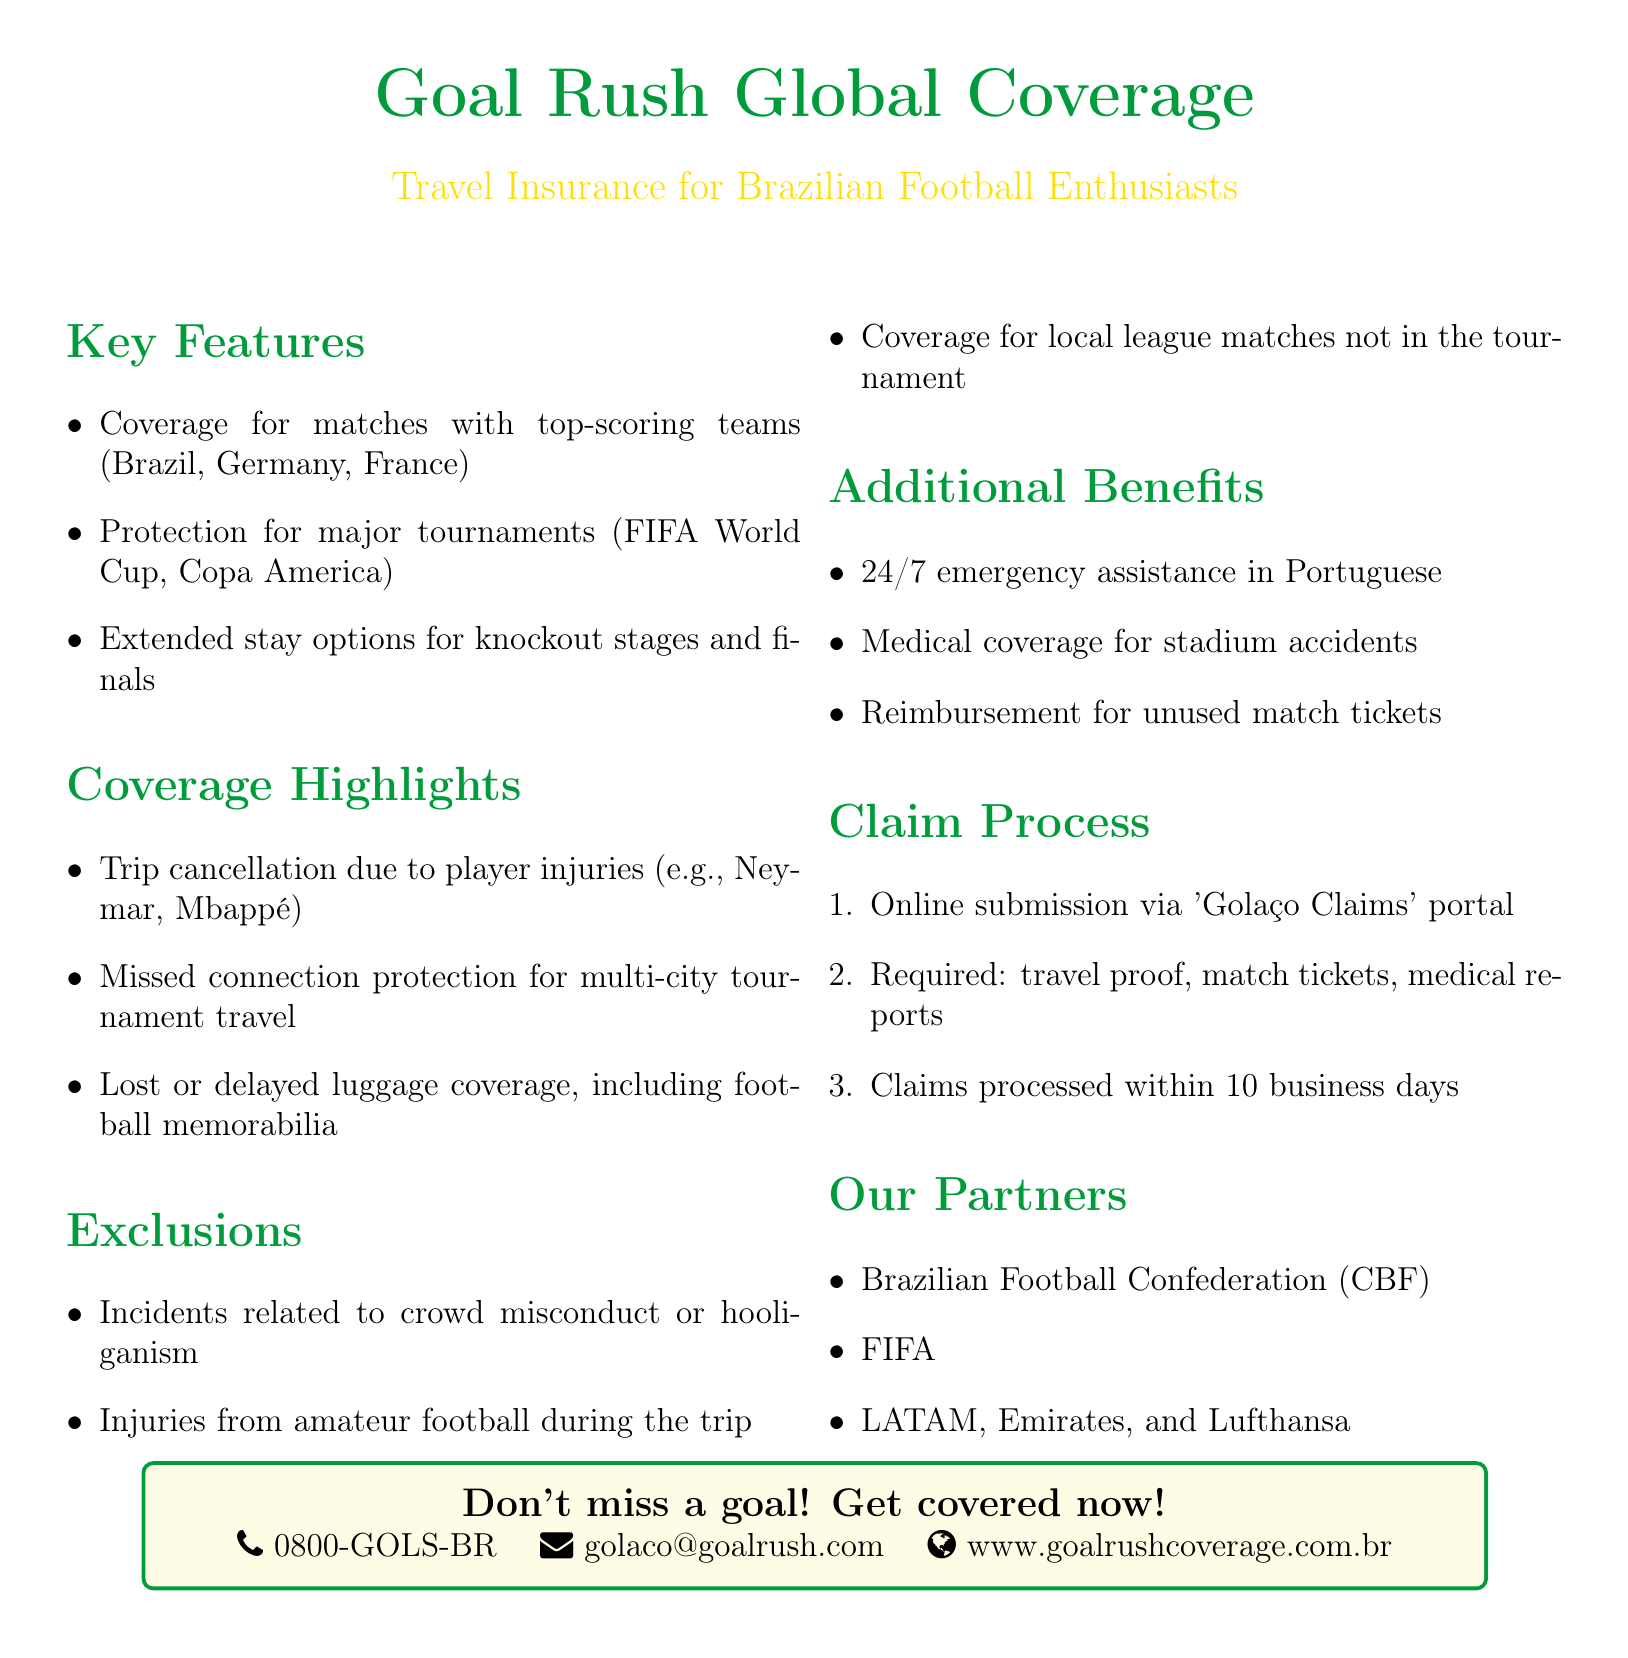What teams are covered by the insurance? The document lists the teams covered under the insurance policy, specifically noting top-scoring teams.
Answer: Brazil, Germany, France What tournaments are included in the coverage? The coverage specifically mentions major international tournaments for football enthusiasts.
Answer: FIFA World Cup, Copa America What is the coverage for missed connections? The document highlights various protection options included with the insurance policy.
Answer: Missed connection protection for multi-city tournament travel What are the exclusions related to player injuries? The policy states what kinds of incidents or activities are not covered under the insurance plan.
Answer: Incidents related to crowd misconduct or hooliganism What is the online claim submission portal called? The document specifies the name of the online submission platform for claims processing.
Answer: Golaço Claims What is the processing time for claims? This information details the duration within which claims are generally handled.
Answer: 10 business days What type of medical coverage is included? The document indicates the nature of the medical coverage available during the trip.
Answer: Medical coverage for stadium accidents How can I contact customer service? The document provides contact information for customer assistance related to the insurance.
Answer: 0800-GOLS-BR What language is the emergency assistance provided in? The policy specifies the language used for 24/7 emergency support.
Answer: Portuguese 